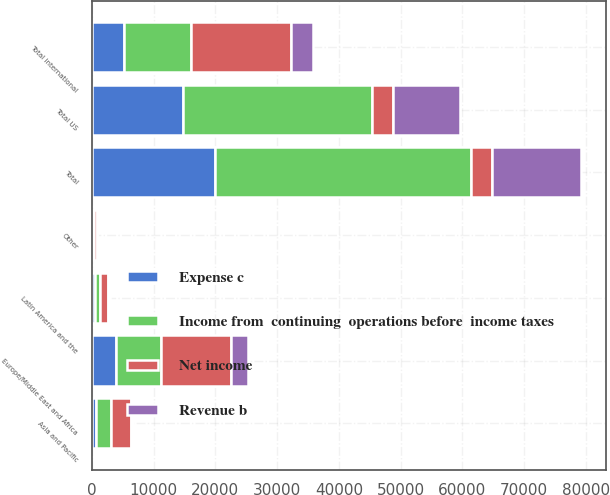Convert chart. <chart><loc_0><loc_0><loc_500><loc_500><stacked_bar_chart><ecel><fcel>Europe/Middle East and Africa<fcel>Asia and Pacific<fcel>Latin America and the<fcel>Other<fcel>Total international<fcel>Total US<fcel>Total<nl><fcel>Net income<fcel>11238<fcel>3144<fcel>1328<fcel>381<fcel>16091<fcel>3370.5<fcel>3370.5<nl><fcel>Income from  continuing  operations before  income taxes<fcel>7367<fcel>2566<fcel>806<fcel>240<fcel>10979<fcel>30572<fcel>41551<nl><fcel>Expense c<fcel>3871<fcel>578<fcel>522<fcel>141<fcel>5112<fcel>14774<fcel>19886<nl><fcel>Revenue b<fcel>2774<fcel>400<fcel>333<fcel>90<fcel>3597<fcel>10847<fcel>14444<nl></chart> 